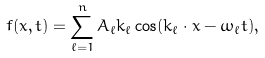<formula> <loc_0><loc_0><loc_500><loc_500>f ( x , t ) = \sum _ { \ell = 1 } ^ { n } A _ { \ell } k _ { \ell } \cos ( k _ { \ell } \cdot x - \omega _ { \ell } t ) ,</formula> 